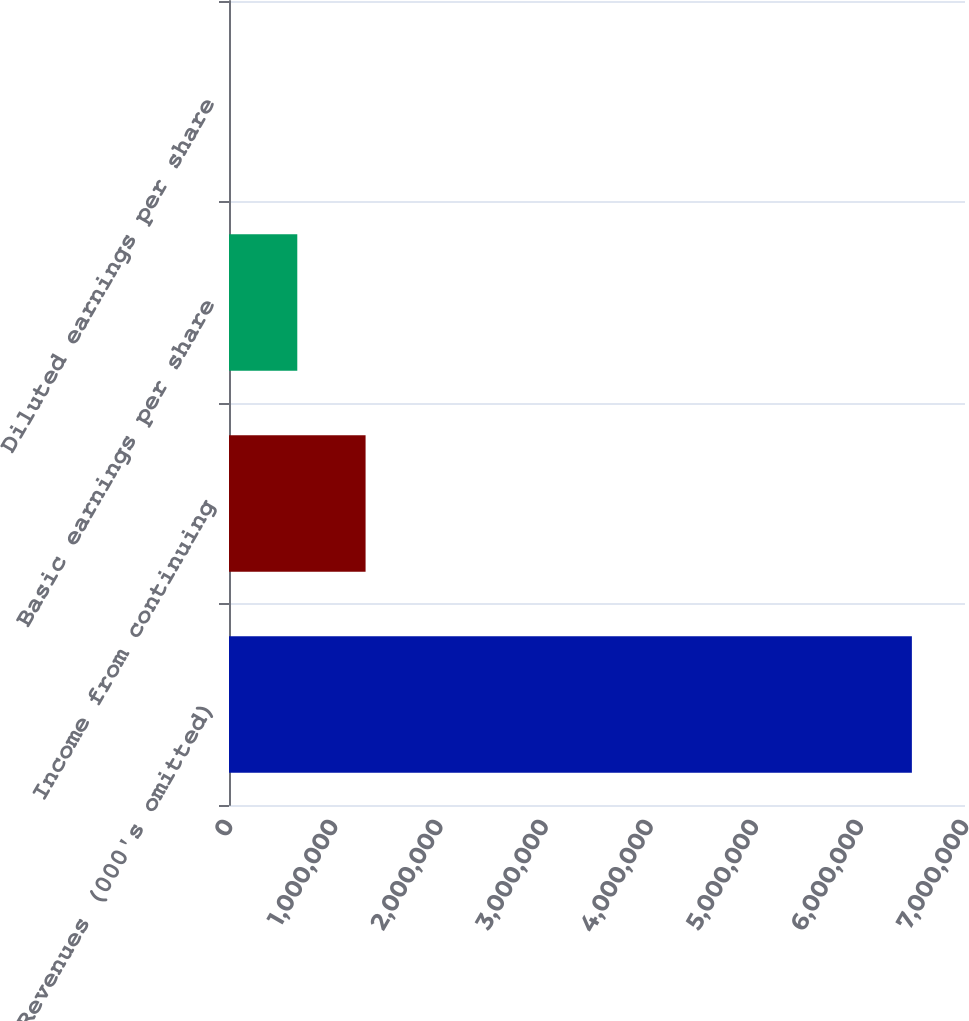Convert chart. <chart><loc_0><loc_0><loc_500><loc_500><bar_chart><fcel>Revenues (000's omitted)<fcel>Income from continuing<fcel>Basic earnings per share<fcel>Diluted earnings per share<nl><fcel>6.4948e+06<fcel>1.29896e+06<fcel>649485<fcel>5.62<nl></chart> 